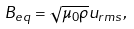<formula> <loc_0><loc_0><loc_500><loc_500>B _ { e q } = \sqrt { \mu _ { 0 } \rho } u _ { r m s } ,</formula> 